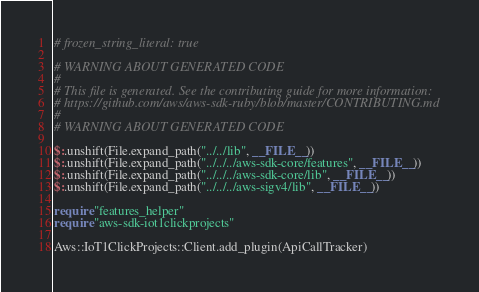Convert code to text. <code><loc_0><loc_0><loc_500><loc_500><_Crystal_># frozen_string_literal: true

# WARNING ABOUT GENERATED CODE
#
# This file is generated. See the contributing guide for more information:
# https://github.com/aws/aws-sdk-ruby/blob/master/CONTRIBUTING.md
#
# WARNING ABOUT GENERATED CODE

$:.unshift(File.expand_path("../../lib", __FILE__))
$:.unshift(File.expand_path("../../../aws-sdk-core/features", __FILE__))
$:.unshift(File.expand_path("../../../aws-sdk-core/lib", __FILE__))
$:.unshift(File.expand_path("../../../aws-sigv4/lib", __FILE__))

require "features_helper"
require "aws-sdk-iot1clickprojects"

Aws::IoT1ClickProjects::Client.add_plugin(ApiCallTracker)
</code> 